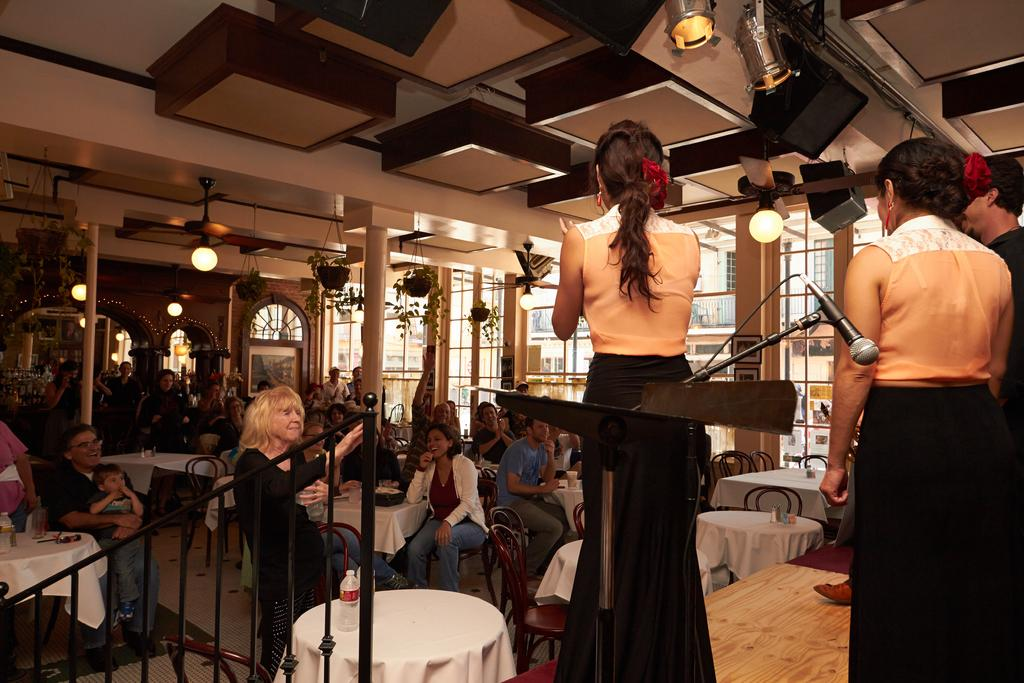How many people are in the room? The number of people in the room cannot be determined from the provided facts. What are some of the people in the room doing? Some people are sitting, and some people are standing. Can you describe the positions of the people in the room? Some people are sitting, and some people are standing. What type of grape is being used as a ball in the room? There is no mention of a grape or any ball in the image, so it cannot be determined from the provided facts. 